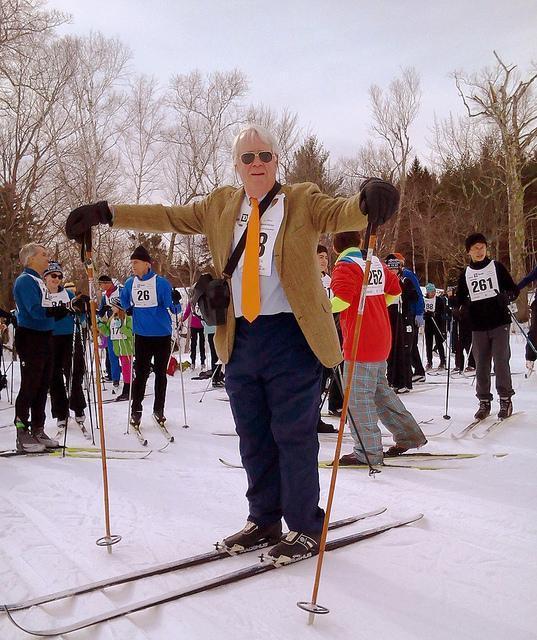How many people are there?
Give a very brief answer. 8. How many ski are there?
Give a very brief answer. 2. How many bears are licking their paws?
Give a very brief answer. 0. 